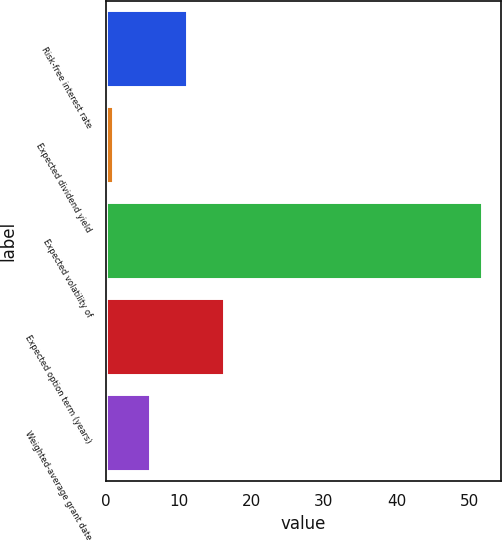Convert chart to OTSL. <chart><loc_0><loc_0><loc_500><loc_500><bar_chart><fcel>Risk-free interest rate<fcel>Expected dividend yield<fcel>Expected volatility of<fcel>Expected option term (years)<fcel>Weighted-average grant date<nl><fcel>11.12<fcel>0.96<fcel>51.8<fcel>16.2<fcel>6.04<nl></chart> 